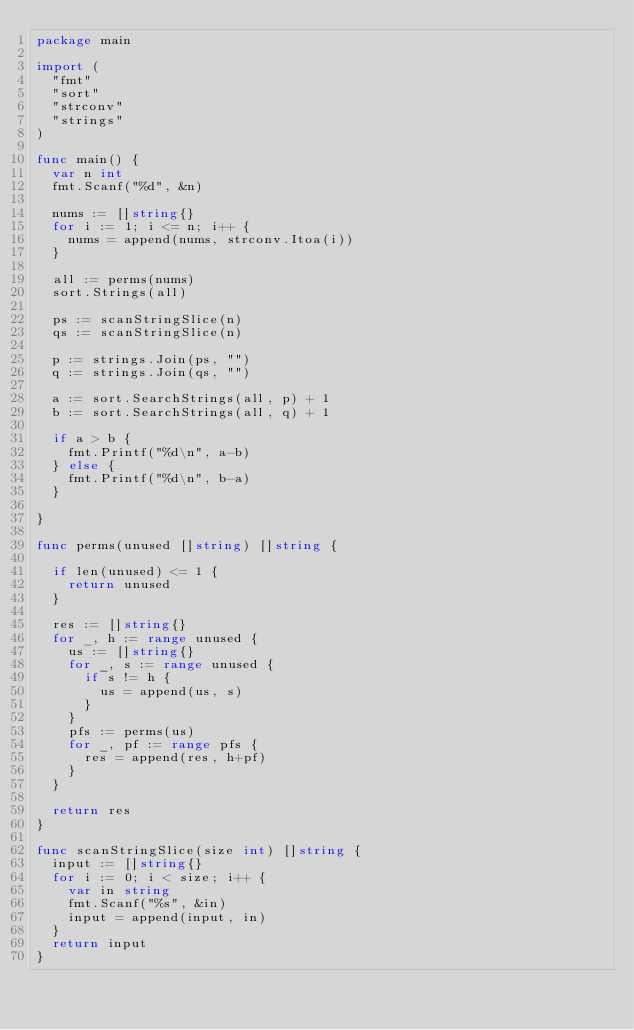Convert code to text. <code><loc_0><loc_0><loc_500><loc_500><_Go_>package main

import (
	"fmt"
	"sort"
	"strconv"
	"strings"
)

func main() {
	var n int
	fmt.Scanf("%d", &n)

	nums := []string{}
	for i := 1; i <= n; i++ {
		nums = append(nums, strconv.Itoa(i))
	}

	all := perms(nums)
	sort.Strings(all)

	ps := scanStringSlice(n)
	qs := scanStringSlice(n)

	p := strings.Join(ps, "")
	q := strings.Join(qs, "")

	a := sort.SearchStrings(all, p) + 1
	b := sort.SearchStrings(all, q) + 1

	if a > b {
		fmt.Printf("%d\n", a-b)
	} else {
		fmt.Printf("%d\n", b-a)
	}

}

func perms(unused []string) []string {

	if len(unused) <= 1 {
		return unused
	}

	res := []string{}
	for _, h := range unused {
		us := []string{}
		for _, s := range unused {
			if s != h {
				us = append(us, s)
			}
		}
		pfs := perms(us)
		for _, pf := range pfs {
			res = append(res, h+pf)
		}
	}

	return res
}

func scanStringSlice(size int) []string {
	input := []string{}
	for i := 0; i < size; i++ {
		var in string
		fmt.Scanf("%s", &in)
		input = append(input, in)
	}
	return input
}
</code> 